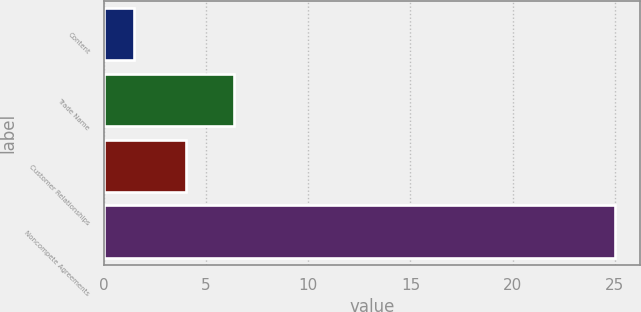Convert chart. <chart><loc_0><loc_0><loc_500><loc_500><bar_chart><fcel>Content<fcel>Trade Name<fcel>Customer Relationships<fcel>Noncompete Agreements<nl><fcel>1.5<fcel>6.35<fcel>4<fcel>25<nl></chart> 